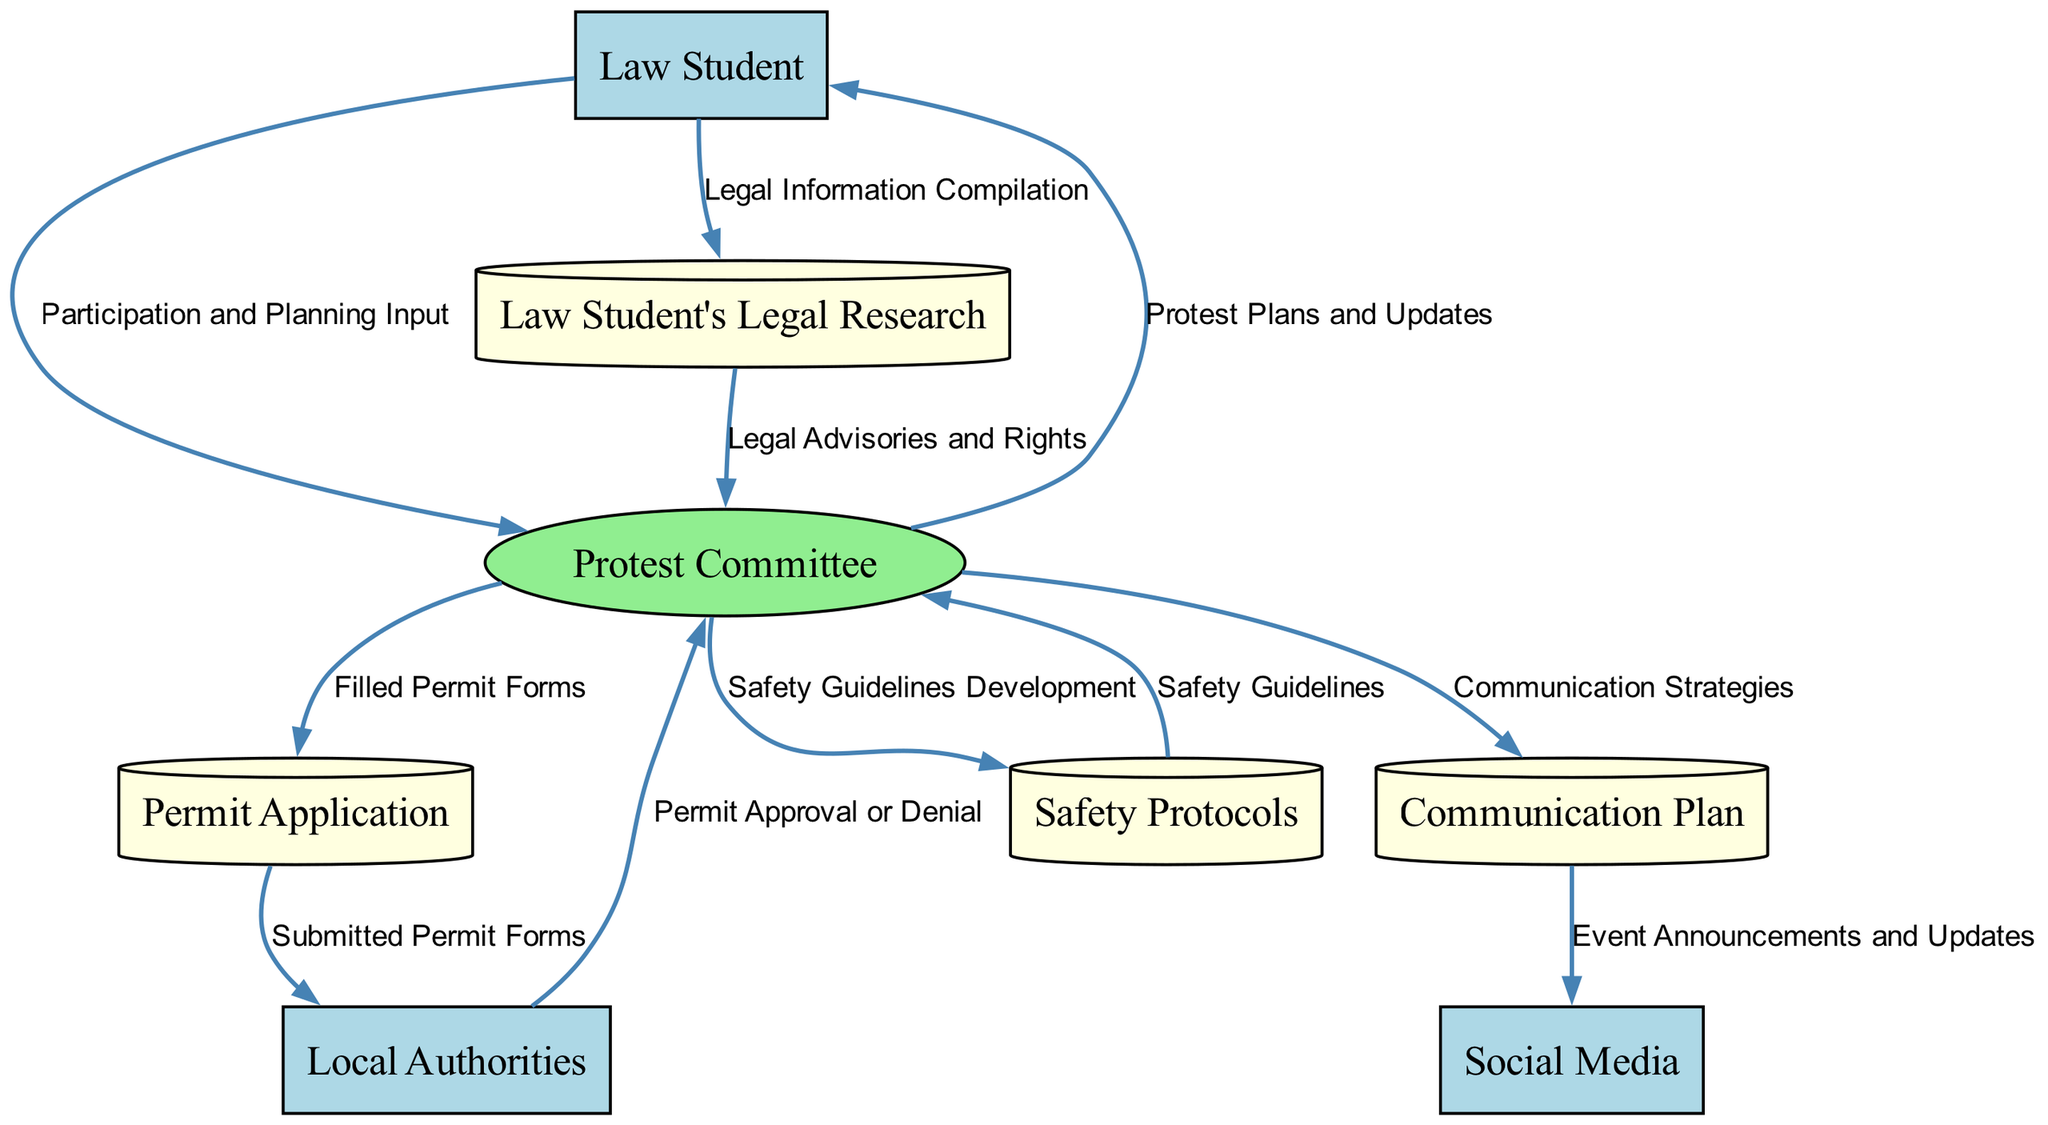What is the role of the Protest Committee in the diagram? The Protest Committee is marked as a Process and is responsible for organizing and managing the protest. It interacts with various entities including the Law Student, Local Authorities, and Data Stores to facilitate the protest planning and execution.
Answer: Organizing and managing the protest How many external entities are present in the diagram? The diagram includes three external entities: Law Student, Local Authorities, and Social Media. Each of these entities interacts with other parts of the diagram, contributing to the overall organization of the protest.
Answer: 3 What data does the Law Student provide to the Protest Committee? The Law Student contributes Participation and Planning Input to the Protest Committee, which is crucial for the overall protest planning process. This input helps the committee understand the desires and legal perspectives from the perspective of participants.
Answer: Participation and Planning Input Which data store receives Legal Advisories and Rights from the Law Student's Legal Research? The Law Student's Legal Research provides Legal Advisories and Rights to the Protest Committee, thus ensuring that the committee is informed about legal aspects relevant to the protest. This helps guide the planning and adherence to legal practices.
Answer: Protest Committee What happens to Permit Application after it is submitted to Local Authorities? After the Permit Application is submitted, the Local Authorities respond with either Permit Approval or Denial. This interaction is critical as it determines whether the protest can take place legally and ensures that the organizers are compliant with local regulations.
Answer: Permit Approval or Denial What role does the Communication Plan play in relation to Social Media? The Communication Plan outlines the Communication Strategies that lead to Event Announcements and Updates being sent to Social Media. This is important for mobilizing participants and keeping them informed about the protest developments through various social media platforms.
Answer: Event Announcements and Updates How does Safety Protocols interact with the Protest Committee? Safety Protocols provide Safety Guidelines to the Protest Committee after being developed. This interaction ensures that there are established safety measures in place that the committee can implement to protect participants during the protest.
Answer: Safety Guidelines Which external entity is responsible for approving protest permits? The Local Authorities are responsible for approving protest permits as they manage compliance with local laws and order during events such as peaceful protests. This role is depicted clearly within the data flow relations in the diagram.
Answer: Local Authorities 